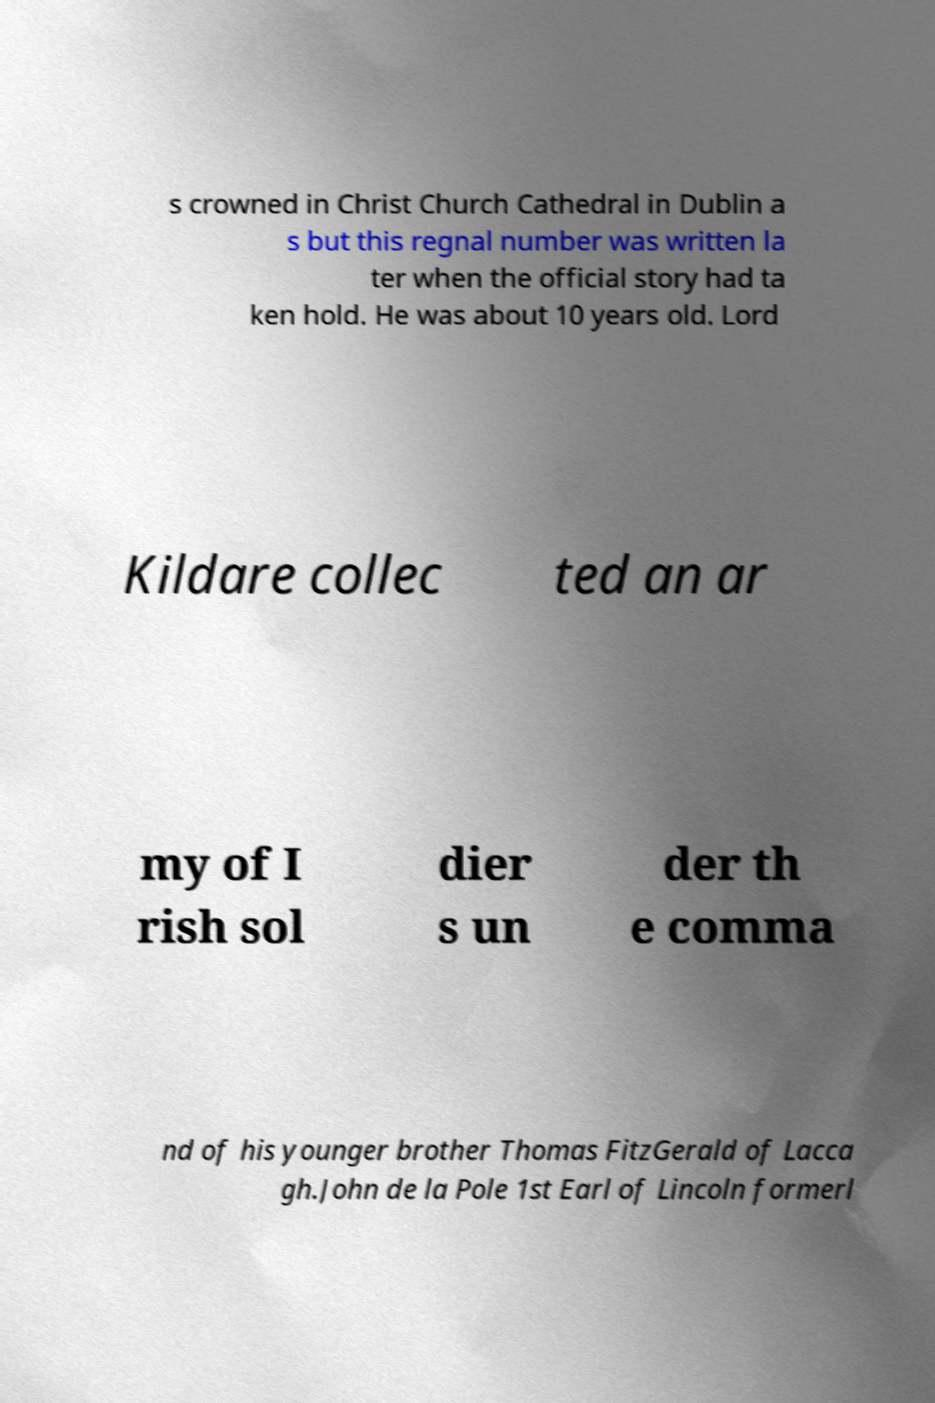I need the written content from this picture converted into text. Can you do that? s crowned in Christ Church Cathedral in Dublin a s but this regnal number was written la ter when the official story had ta ken hold. He was about 10 years old. Lord Kildare collec ted an ar my of I rish sol dier s un der th e comma nd of his younger brother Thomas FitzGerald of Lacca gh.John de la Pole 1st Earl of Lincoln formerl 